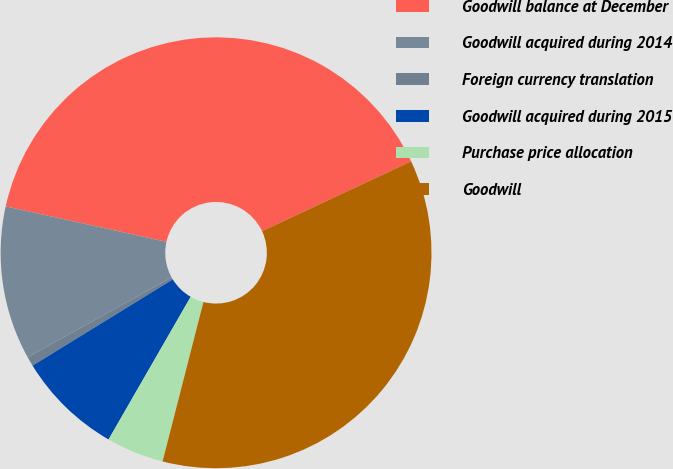Convert chart to OTSL. <chart><loc_0><loc_0><loc_500><loc_500><pie_chart><fcel>Goodwill balance at December<fcel>Goodwill acquired during 2014<fcel>Foreign currency translation<fcel>Goodwill acquired during 2015<fcel>Purchase price allocation<fcel>Goodwill<nl><fcel>39.57%<fcel>11.51%<fcel>0.72%<fcel>7.91%<fcel>4.32%<fcel>35.97%<nl></chart> 